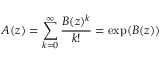<formula> <loc_0><loc_0><loc_500><loc_500>A ( z ) = \sum _ { k = 0 } ^ { \infty } { \frac { B ( z ) ^ { k } } { k ! } } = \exp ( B ( z ) )</formula> 